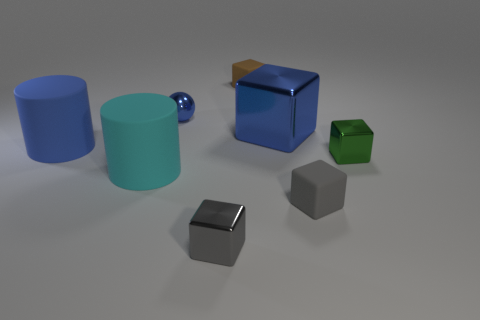What number of large cyan things have the same material as the big cyan cylinder?
Your response must be concise. 0. There is another object that is the same shape as the big blue rubber thing; what size is it?
Provide a short and direct response. Large. What is the material of the tiny green object?
Offer a terse response. Metal. There is a gray object right of the tiny rubber thing behind the large blue thing that is to the left of the brown thing; what is its material?
Ensure brevity in your answer.  Rubber. Is there anything else that has the same shape as the green shiny thing?
Your answer should be compact. Yes. What color is the other big rubber object that is the same shape as the blue matte thing?
Offer a terse response. Cyan. There is a small rubber cube that is in front of the blue shiny ball; is it the same color as the shiny thing in front of the cyan matte cylinder?
Your answer should be very brief. Yes. Are there more large cyan matte cylinders on the right side of the green metal block than balls?
Your answer should be very brief. No. How many other things are the same size as the blue matte cylinder?
Keep it short and to the point. 2. What number of tiny objects are both on the left side of the blue metal cube and in front of the cyan cylinder?
Provide a succinct answer. 1. 